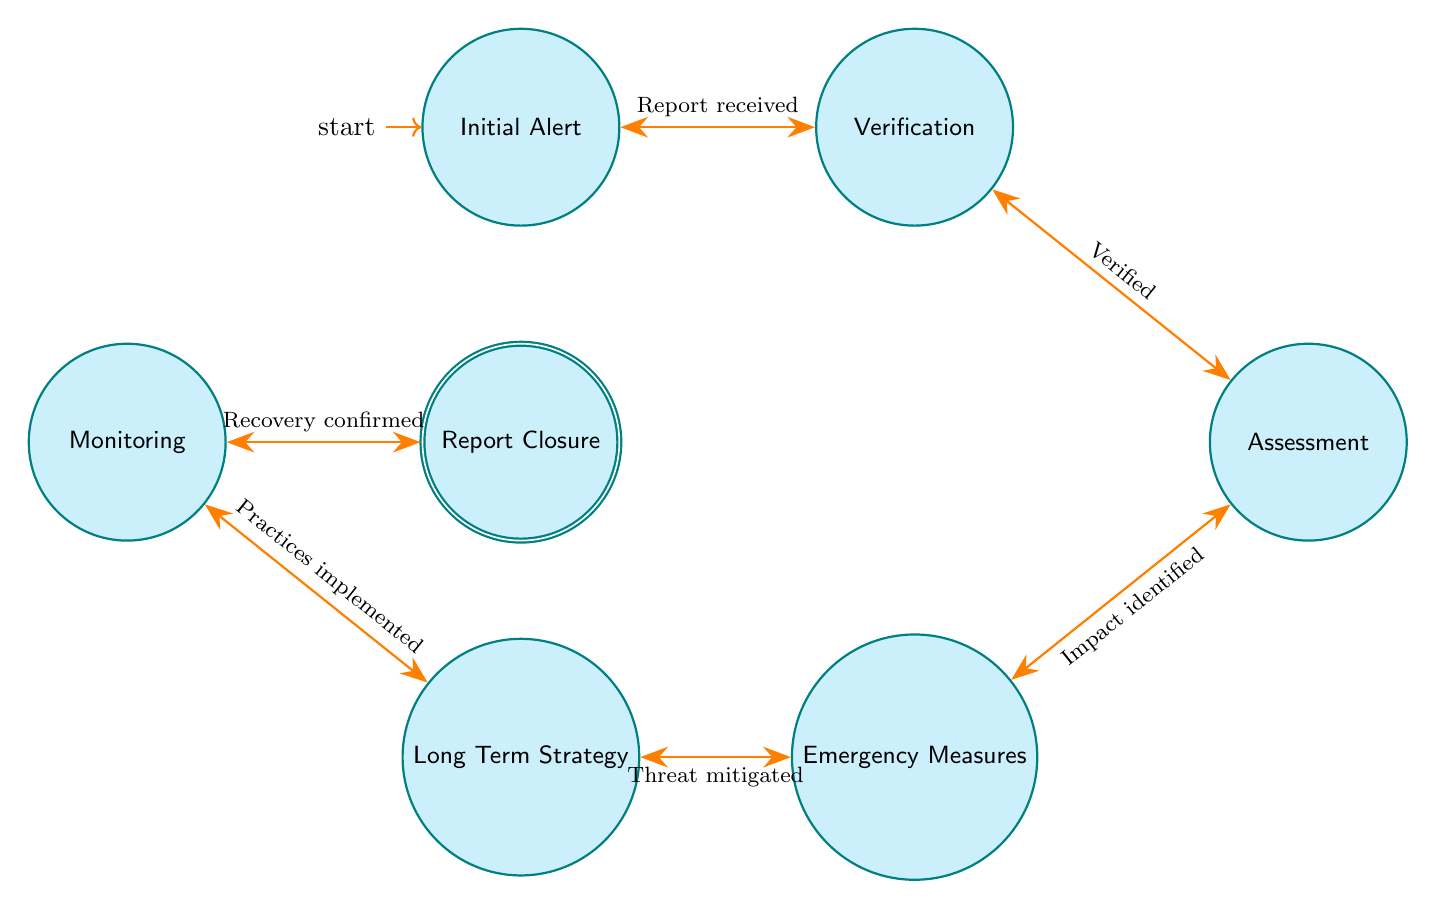What is the first state in the diagram? The first state listed in the diagram is "Initial Alert," which is also marked as the starting point of the finite state machine.
Answer: Initial Alert How many states are there in total? Counting all the unique states mentioned in the diagram, there are seven states: Initial Alert, Verification, Assessment, Emergency Measures, Long Term Strategy, Monitoring, and Report Closure.
Answer: 7 What condition leads from Emergency Measures to Long Term Strategy? The transition from Emergency Measures to Long Term Strategy occurs when the condition "Immediate threat mitigated" is satisfied, according to the diagram.
Answer: Immediate threat mitigated What is the relationship between Verification and Assessment? Verification leads to Assessment; specifically, the transition occurs when the condition "Report verified by marine biologists" is met.
Answer: Leads to What state comes after Monitoring? After Monitoring, the next state is Report Closure. This transition occurs upon the condition "Confirmed recovery of fish stocks."
Answer: Report Closure What is the condition for moving from Assessment to Emergency Measures? The condition necessary for transitioning from Assessment to Emergency Measures is when a "Significant impact identified" is acknowledged.
Answer: Significant impact identified Which state is the accepting state in the diagram? The accepting state is Report Closure, which signifies that the process has completed following successful mitigation and recovery confirmation.
Answer: Report Closure What overall process does the diagram illustrate? The diagram illustrates the emergency response workflow for overfishing incidents, detailing the steps from detection to closure of incident reports.
Answer: Emergency response for overfishing incidents What condition initiates the transition from Initial Alert to Verification? The transition from Initial Alert to Verification starts when a report of overfishing is received. The condition is simply stated as "Overfishing report received."
Answer: Overfishing report received 